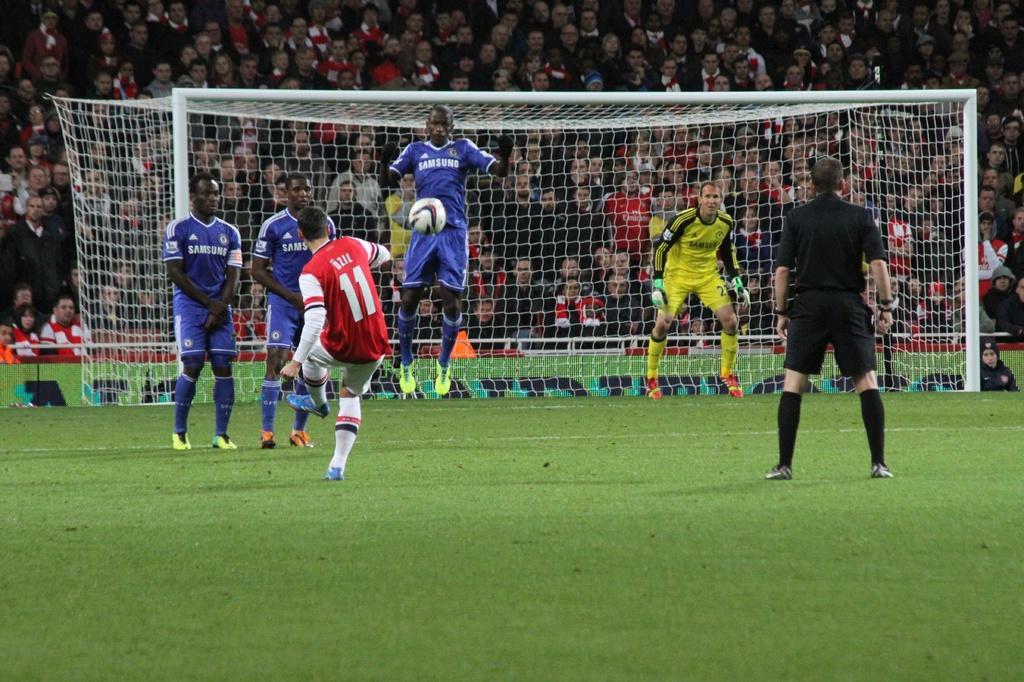Can you describe this image briefly? In this image I can see few persons wearing blue colored jersey, a person wearing black colored dress, a person wearing red and white colored jersey and a person wearing yellow and black colored jersey are standing. I can see a ball over here. In the background I can see the goal post, some grass and number of persons are sitting in the stadium. 